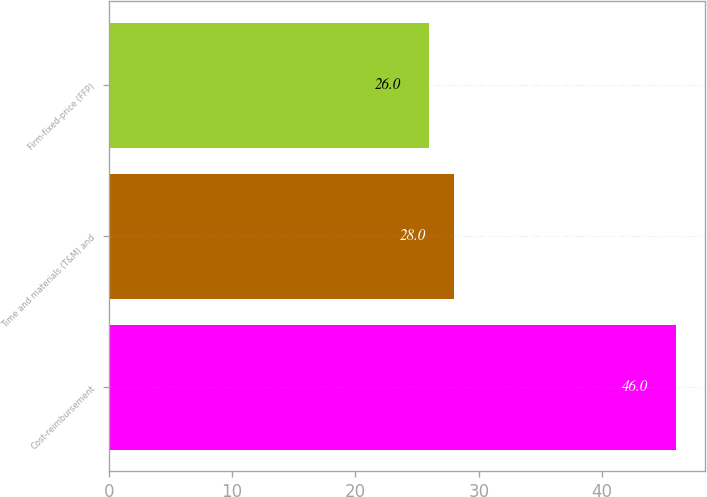Convert chart. <chart><loc_0><loc_0><loc_500><loc_500><bar_chart><fcel>Cost-reimbursement<fcel>Time and materials (T&M) and<fcel>Firm-fixed-price (FFP)<nl><fcel>46<fcel>28<fcel>26<nl></chart> 